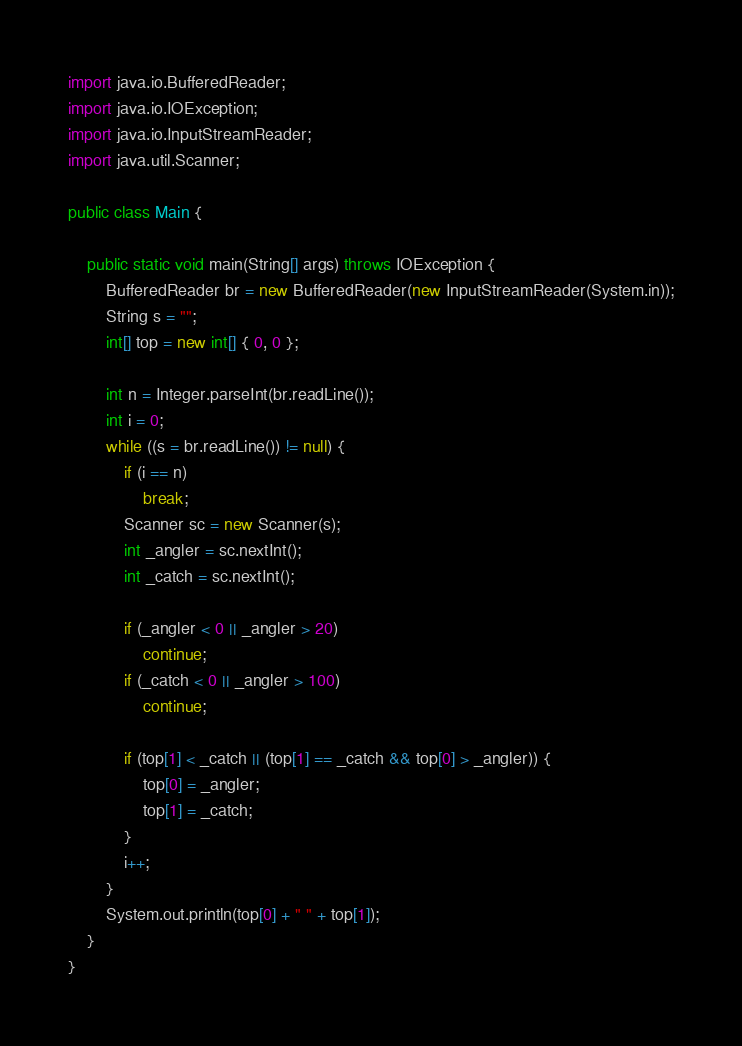Convert code to text. <code><loc_0><loc_0><loc_500><loc_500><_Java_>import java.io.BufferedReader;
import java.io.IOException;
import java.io.InputStreamReader;
import java.util.Scanner;

public class Main {

	public static void main(String[] args) throws IOException {
		BufferedReader br = new BufferedReader(new InputStreamReader(System.in));
		String s = "";
		int[] top = new int[] { 0, 0 };

		int n = Integer.parseInt(br.readLine());
		int i = 0;
		while ((s = br.readLine()) != null) {
			if (i == n)
				break;
			Scanner sc = new Scanner(s);
			int _angler = sc.nextInt();
			int _catch = sc.nextInt();

			if (_angler < 0 || _angler > 20)
				continue;
			if (_catch < 0 || _angler > 100)
				continue;

			if (top[1] < _catch || (top[1] == _catch && top[0] > _angler)) {
				top[0] = _angler;
				top[1] = _catch;
			}
			i++;
		}
		System.out.println(top[0] + " " + top[1]);
	}
}</code> 